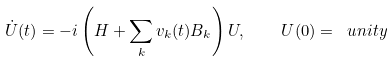<formula> <loc_0><loc_0><loc_500><loc_500>\dot { U } ( t ) = - i \left ( H + \sum _ { k } v _ { k } ( t ) B _ { k } \right ) U , \quad U ( 0 ) = \ u n i t y</formula> 